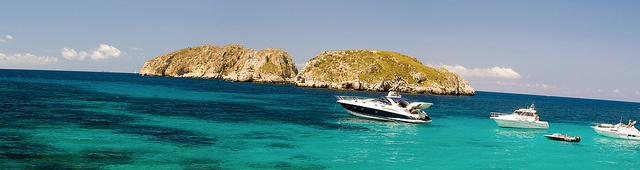Describe the objects in this image and their specific colors. I can see boat in darkgray, white, black, and gray tones, boat in darkgray, white, lightblue, and turquoise tones, boat in darkgray, white, lightblue, and teal tones, and boat in darkgray, black, lightgray, and gray tones in this image. 